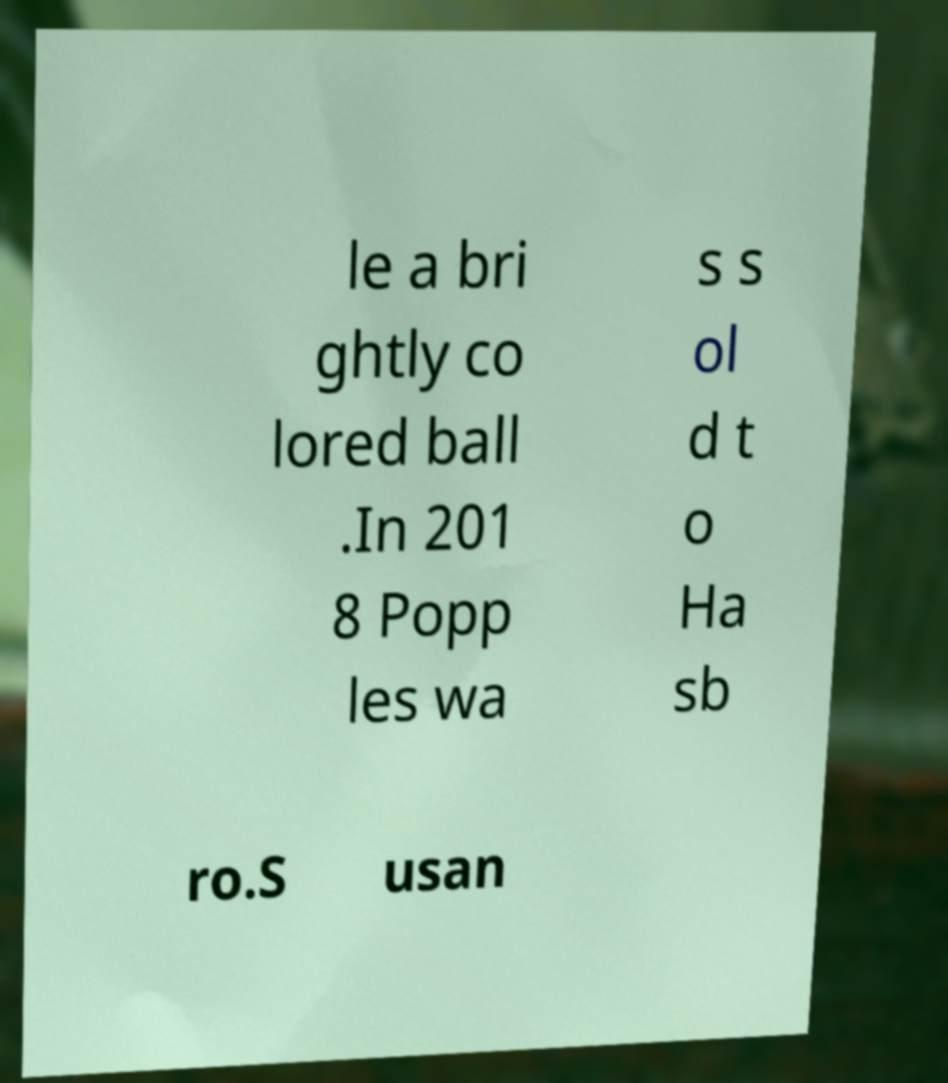Could you assist in decoding the text presented in this image and type it out clearly? le a bri ghtly co lored ball .In 201 8 Popp les wa s s ol d t o Ha sb ro.S usan 